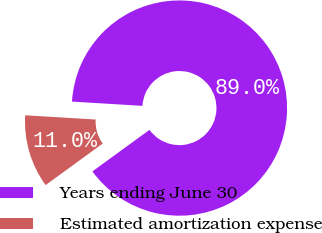Convert chart. <chart><loc_0><loc_0><loc_500><loc_500><pie_chart><fcel>Years ending June 30<fcel>Estimated amortization expense<nl><fcel>89.03%<fcel>10.97%<nl></chart> 